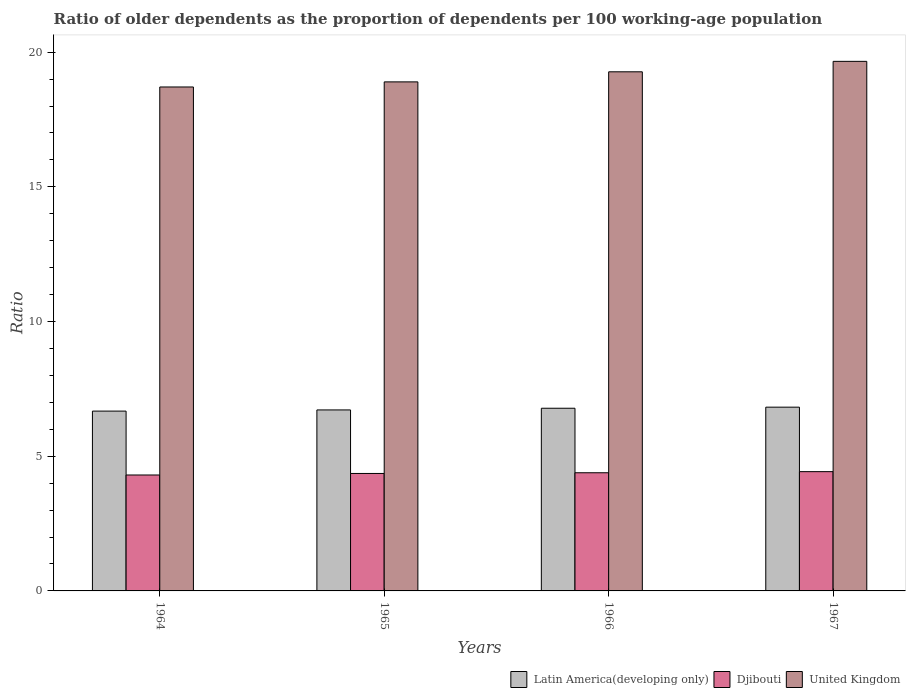How many different coloured bars are there?
Your answer should be compact. 3. How many groups of bars are there?
Your response must be concise. 4. Are the number of bars per tick equal to the number of legend labels?
Your response must be concise. Yes. Are the number of bars on each tick of the X-axis equal?
Your response must be concise. Yes. How many bars are there on the 4th tick from the left?
Your answer should be very brief. 3. What is the label of the 1st group of bars from the left?
Your response must be concise. 1964. What is the age dependency ratio(old) in United Kingdom in 1967?
Your response must be concise. 19.66. Across all years, what is the maximum age dependency ratio(old) in Djibouti?
Ensure brevity in your answer.  4.43. Across all years, what is the minimum age dependency ratio(old) in Latin America(developing only)?
Your answer should be very brief. 6.68. In which year was the age dependency ratio(old) in United Kingdom maximum?
Provide a short and direct response. 1967. In which year was the age dependency ratio(old) in United Kingdom minimum?
Keep it short and to the point. 1964. What is the total age dependency ratio(old) in Latin America(developing only) in the graph?
Your answer should be very brief. 27. What is the difference between the age dependency ratio(old) in United Kingdom in 1964 and that in 1966?
Offer a very short reply. -0.56. What is the difference between the age dependency ratio(old) in Djibouti in 1965 and the age dependency ratio(old) in United Kingdom in 1964?
Give a very brief answer. -14.35. What is the average age dependency ratio(old) in United Kingdom per year?
Give a very brief answer. 19.13. In the year 1967, what is the difference between the age dependency ratio(old) in Latin America(developing only) and age dependency ratio(old) in Djibouti?
Your answer should be very brief. 2.39. In how many years, is the age dependency ratio(old) in Latin America(developing only) greater than 8?
Provide a short and direct response. 0. What is the ratio of the age dependency ratio(old) in Djibouti in 1964 to that in 1965?
Offer a very short reply. 0.99. Is the age dependency ratio(old) in Djibouti in 1965 less than that in 1966?
Ensure brevity in your answer.  Yes. Is the difference between the age dependency ratio(old) in Latin America(developing only) in 1964 and 1966 greater than the difference between the age dependency ratio(old) in Djibouti in 1964 and 1966?
Offer a very short reply. No. What is the difference between the highest and the second highest age dependency ratio(old) in Djibouti?
Your response must be concise. 0.04. What is the difference between the highest and the lowest age dependency ratio(old) in Djibouti?
Your answer should be very brief. 0.12. In how many years, is the age dependency ratio(old) in United Kingdom greater than the average age dependency ratio(old) in United Kingdom taken over all years?
Your response must be concise. 2. Is the sum of the age dependency ratio(old) in United Kingdom in 1965 and 1966 greater than the maximum age dependency ratio(old) in Djibouti across all years?
Offer a terse response. Yes. What does the 2nd bar from the right in 1967 represents?
Give a very brief answer. Djibouti. How many years are there in the graph?
Provide a short and direct response. 4. What is the difference between two consecutive major ticks on the Y-axis?
Your response must be concise. 5. Does the graph contain any zero values?
Keep it short and to the point. No. Does the graph contain grids?
Ensure brevity in your answer.  No. How many legend labels are there?
Offer a very short reply. 3. What is the title of the graph?
Provide a short and direct response. Ratio of older dependents as the proportion of dependents per 100 working-age population. Does "Azerbaijan" appear as one of the legend labels in the graph?
Your response must be concise. No. What is the label or title of the Y-axis?
Make the answer very short. Ratio. What is the Ratio of Latin America(developing only) in 1964?
Make the answer very short. 6.68. What is the Ratio in Djibouti in 1964?
Your answer should be compact. 4.3. What is the Ratio in United Kingdom in 1964?
Ensure brevity in your answer.  18.71. What is the Ratio of Latin America(developing only) in 1965?
Ensure brevity in your answer.  6.72. What is the Ratio of Djibouti in 1965?
Provide a short and direct response. 4.36. What is the Ratio of United Kingdom in 1965?
Ensure brevity in your answer.  18.9. What is the Ratio of Latin America(developing only) in 1966?
Ensure brevity in your answer.  6.78. What is the Ratio in Djibouti in 1966?
Give a very brief answer. 4.39. What is the Ratio of United Kingdom in 1966?
Offer a terse response. 19.27. What is the Ratio in Latin America(developing only) in 1967?
Your answer should be compact. 6.82. What is the Ratio of Djibouti in 1967?
Your answer should be compact. 4.43. What is the Ratio in United Kingdom in 1967?
Provide a succinct answer. 19.66. Across all years, what is the maximum Ratio in Latin America(developing only)?
Make the answer very short. 6.82. Across all years, what is the maximum Ratio of Djibouti?
Ensure brevity in your answer.  4.43. Across all years, what is the maximum Ratio in United Kingdom?
Make the answer very short. 19.66. Across all years, what is the minimum Ratio of Latin America(developing only)?
Give a very brief answer. 6.68. Across all years, what is the minimum Ratio in Djibouti?
Your answer should be compact. 4.3. Across all years, what is the minimum Ratio of United Kingdom?
Offer a very short reply. 18.71. What is the total Ratio of Latin America(developing only) in the graph?
Your response must be concise. 27. What is the total Ratio of Djibouti in the graph?
Your response must be concise. 17.48. What is the total Ratio of United Kingdom in the graph?
Your response must be concise. 76.53. What is the difference between the Ratio of Latin America(developing only) in 1964 and that in 1965?
Provide a short and direct response. -0.04. What is the difference between the Ratio in Djibouti in 1964 and that in 1965?
Your answer should be very brief. -0.06. What is the difference between the Ratio of United Kingdom in 1964 and that in 1965?
Offer a very short reply. -0.19. What is the difference between the Ratio of Latin America(developing only) in 1964 and that in 1966?
Make the answer very short. -0.11. What is the difference between the Ratio of Djibouti in 1964 and that in 1966?
Ensure brevity in your answer.  -0.08. What is the difference between the Ratio of United Kingdom in 1964 and that in 1966?
Give a very brief answer. -0.56. What is the difference between the Ratio of Latin America(developing only) in 1964 and that in 1967?
Provide a short and direct response. -0.15. What is the difference between the Ratio of Djibouti in 1964 and that in 1967?
Provide a short and direct response. -0.12. What is the difference between the Ratio in United Kingdom in 1964 and that in 1967?
Ensure brevity in your answer.  -0.95. What is the difference between the Ratio of Latin America(developing only) in 1965 and that in 1966?
Ensure brevity in your answer.  -0.06. What is the difference between the Ratio of Djibouti in 1965 and that in 1966?
Keep it short and to the point. -0.03. What is the difference between the Ratio in United Kingdom in 1965 and that in 1966?
Give a very brief answer. -0.37. What is the difference between the Ratio of Latin America(developing only) in 1965 and that in 1967?
Offer a very short reply. -0.1. What is the difference between the Ratio in Djibouti in 1965 and that in 1967?
Provide a short and direct response. -0.07. What is the difference between the Ratio in United Kingdom in 1965 and that in 1967?
Keep it short and to the point. -0.76. What is the difference between the Ratio of Latin America(developing only) in 1966 and that in 1967?
Your response must be concise. -0.04. What is the difference between the Ratio in Djibouti in 1966 and that in 1967?
Provide a short and direct response. -0.04. What is the difference between the Ratio in United Kingdom in 1966 and that in 1967?
Offer a very short reply. -0.39. What is the difference between the Ratio of Latin America(developing only) in 1964 and the Ratio of Djibouti in 1965?
Make the answer very short. 2.31. What is the difference between the Ratio in Latin America(developing only) in 1964 and the Ratio in United Kingdom in 1965?
Offer a very short reply. -12.22. What is the difference between the Ratio of Djibouti in 1964 and the Ratio of United Kingdom in 1965?
Your answer should be compact. -14.59. What is the difference between the Ratio of Latin America(developing only) in 1964 and the Ratio of Djibouti in 1966?
Your response must be concise. 2.29. What is the difference between the Ratio in Latin America(developing only) in 1964 and the Ratio in United Kingdom in 1966?
Offer a terse response. -12.6. What is the difference between the Ratio of Djibouti in 1964 and the Ratio of United Kingdom in 1966?
Make the answer very short. -14.97. What is the difference between the Ratio in Latin America(developing only) in 1964 and the Ratio in Djibouti in 1967?
Provide a short and direct response. 2.25. What is the difference between the Ratio of Latin America(developing only) in 1964 and the Ratio of United Kingdom in 1967?
Provide a short and direct response. -12.98. What is the difference between the Ratio in Djibouti in 1964 and the Ratio in United Kingdom in 1967?
Offer a terse response. -15.35. What is the difference between the Ratio in Latin America(developing only) in 1965 and the Ratio in Djibouti in 1966?
Your response must be concise. 2.33. What is the difference between the Ratio in Latin America(developing only) in 1965 and the Ratio in United Kingdom in 1966?
Provide a short and direct response. -12.55. What is the difference between the Ratio in Djibouti in 1965 and the Ratio in United Kingdom in 1966?
Make the answer very short. -14.91. What is the difference between the Ratio in Latin America(developing only) in 1965 and the Ratio in Djibouti in 1967?
Give a very brief answer. 2.29. What is the difference between the Ratio of Latin America(developing only) in 1965 and the Ratio of United Kingdom in 1967?
Your answer should be very brief. -12.94. What is the difference between the Ratio in Djibouti in 1965 and the Ratio in United Kingdom in 1967?
Your answer should be compact. -15.3. What is the difference between the Ratio in Latin America(developing only) in 1966 and the Ratio in Djibouti in 1967?
Your answer should be compact. 2.35. What is the difference between the Ratio in Latin America(developing only) in 1966 and the Ratio in United Kingdom in 1967?
Make the answer very short. -12.88. What is the difference between the Ratio of Djibouti in 1966 and the Ratio of United Kingdom in 1967?
Provide a succinct answer. -15.27. What is the average Ratio of Latin America(developing only) per year?
Provide a succinct answer. 6.75. What is the average Ratio of Djibouti per year?
Make the answer very short. 4.37. What is the average Ratio in United Kingdom per year?
Your answer should be compact. 19.13. In the year 1964, what is the difference between the Ratio in Latin America(developing only) and Ratio in Djibouti?
Offer a very short reply. 2.37. In the year 1964, what is the difference between the Ratio of Latin America(developing only) and Ratio of United Kingdom?
Ensure brevity in your answer.  -12.03. In the year 1964, what is the difference between the Ratio of Djibouti and Ratio of United Kingdom?
Your answer should be very brief. -14.4. In the year 1965, what is the difference between the Ratio in Latin America(developing only) and Ratio in Djibouti?
Keep it short and to the point. 2.36. In the year 1965, what is the difference between the Ratio in Latin America(developing only) and Ratio in United Kingdom?
Provide a short and direct response. -12.18. In the year 1965, what is the difference between the Ratio in Djibouti and Ratio in United Kingdom?
Keep it short and to the point. -14.54. In the year 1966, what is the difference between the Ratio of Latin America(developing only) and Ratio of Djibouti?
Your response must be concise. 2.39. In the year 1966, what is the difference between the Ratio in Latin America(developing only) and Ratio in United Kingdom?
Your answer should be very brief. -12.49. In the year 1966, what is the difference between the Ratio in Djibouti and Ratio in United Kingdom?
Make the answer very short. -14.88. In the year 1967, what is the difference between the Ratio in Latin America(developing only) and Ratio in Djibouti?
Offer a terse response. 2.39. In the year 1967, what is the difference between the Ratio of Latin America(developing only) and Ratio of United Kingdom?
Your answer should be compact. -12.84. In the year 1967, what is the difference between the Ratio in Djibouti and Ratio in United Kingdom?
Your response must be concise. -15.23. What is the ratio of the Ratio of Latin America(developing only) in 1964 to that in 1965?
Provide a short and direct response. 0.99. What is the ratio of the Ratio of Djibouti in 1964 to that in 1965?
Your answer should be compact. 0.99. What is the ratio of the Ratio of Latin America(developing only) in 1964 to that in 1966?
Ensure brevity in your answer.  0.98. What is the ratio of the Ratio of Djibouti in 1964 to that in 1966?
Ensure brevity in your answer.  0.98. What is the ratio of the Ratio in United Kingdom in 1964 to that in 1966?
Your response must be concise. 0.97. What is the ratio of the Ratio of Latin America(developing only) in 1964 to that in 1967?
Provide a short and direct response. 0.98. What is the ratio of the Ratio of United Kingdom in 1964 to that in 1967?
Your response must be concise. 0.95. What is the ratio of the Ratio in Djibouti in 1965 to that in 1966?
Your answer should be compact. 0.99. What is the ratio of the Ratio in United Kingdom in 1965 to that in 1966?
Make the answer very short. 0.98. What is the ratio of the Ratio in Latin America(developing only) in 1965 to that in 1967?
Your answer should be compact. 0.98. What is the ratio of the Ratio in Djibouti in 1965 to that in 1967?
Offer a terse response. 0.98. What is the ratio of the Ratio of United Kingdom in 1965 to that in 1967?
Offer a very short reply. 0.96. What is the ratio of the Ratio of Djibouti in 1966 to that in 1967?
Offer a terse response. 0.99. What is the ratio of the Ratio of United Kingdom in 1966 to that in 1967?
Give a very brief answer. 0.98. What is the difference between the highest and the second highest Ratio of Latin America(developing only)?
Keep it short and to the point. 0.04. What is the difference between the highest and the second highest Ratio of Djibouti?
Your answer should be compact. 0.04. What is the difference between the highest and the second highest Ratio in United Kingdom?
Make the answer very short. 0.39. What is the difference between the highest and the lowest Ratio in Latin America(developing only)?
Provide a succinct answer. 0.15. What is the difference between the highest and the lowest Ratio of Djibouti?
Provide a succinct answer. 0.12. What is the difference between the highest and the lowest Ratio in United Kingdom?
Your response must be concise. 0.95. 